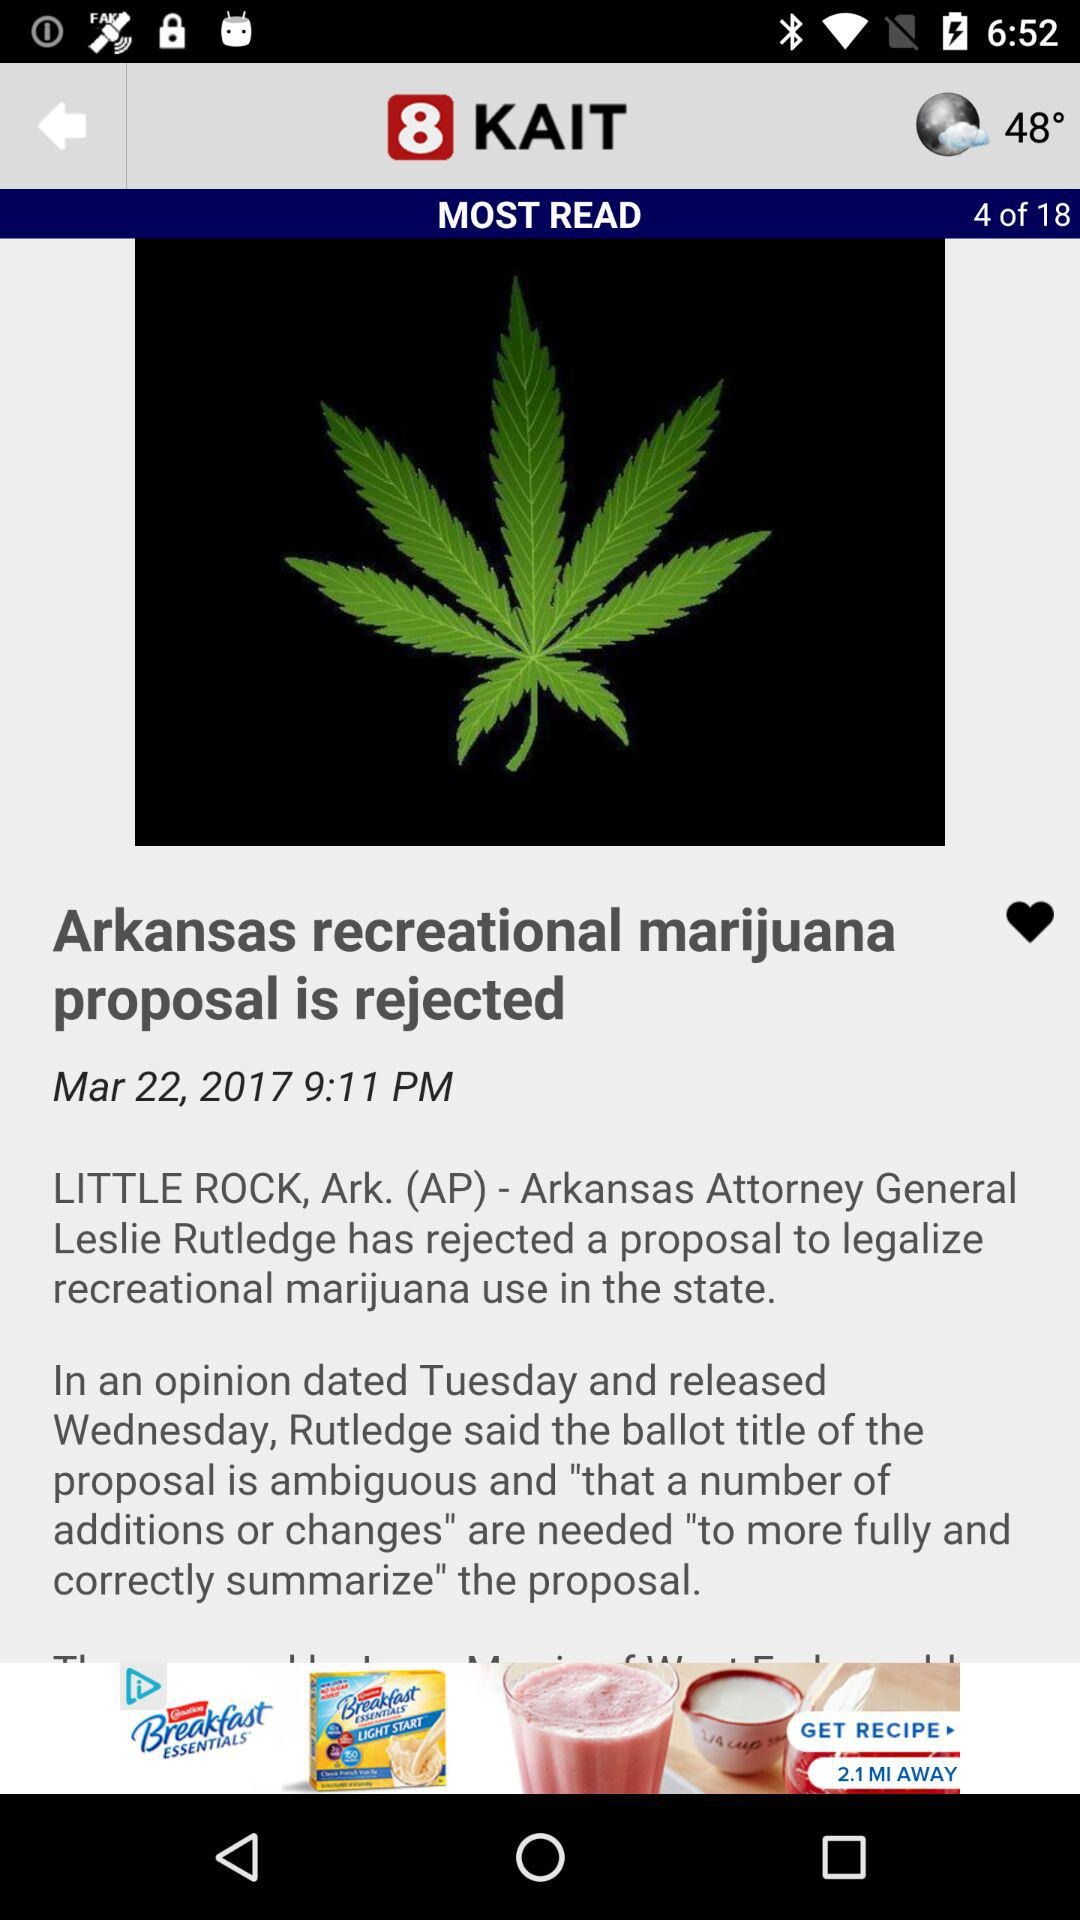At what date was news "Arkansas recreational marijuana proposal is rejected" posted? The date was March 22, 2017. 